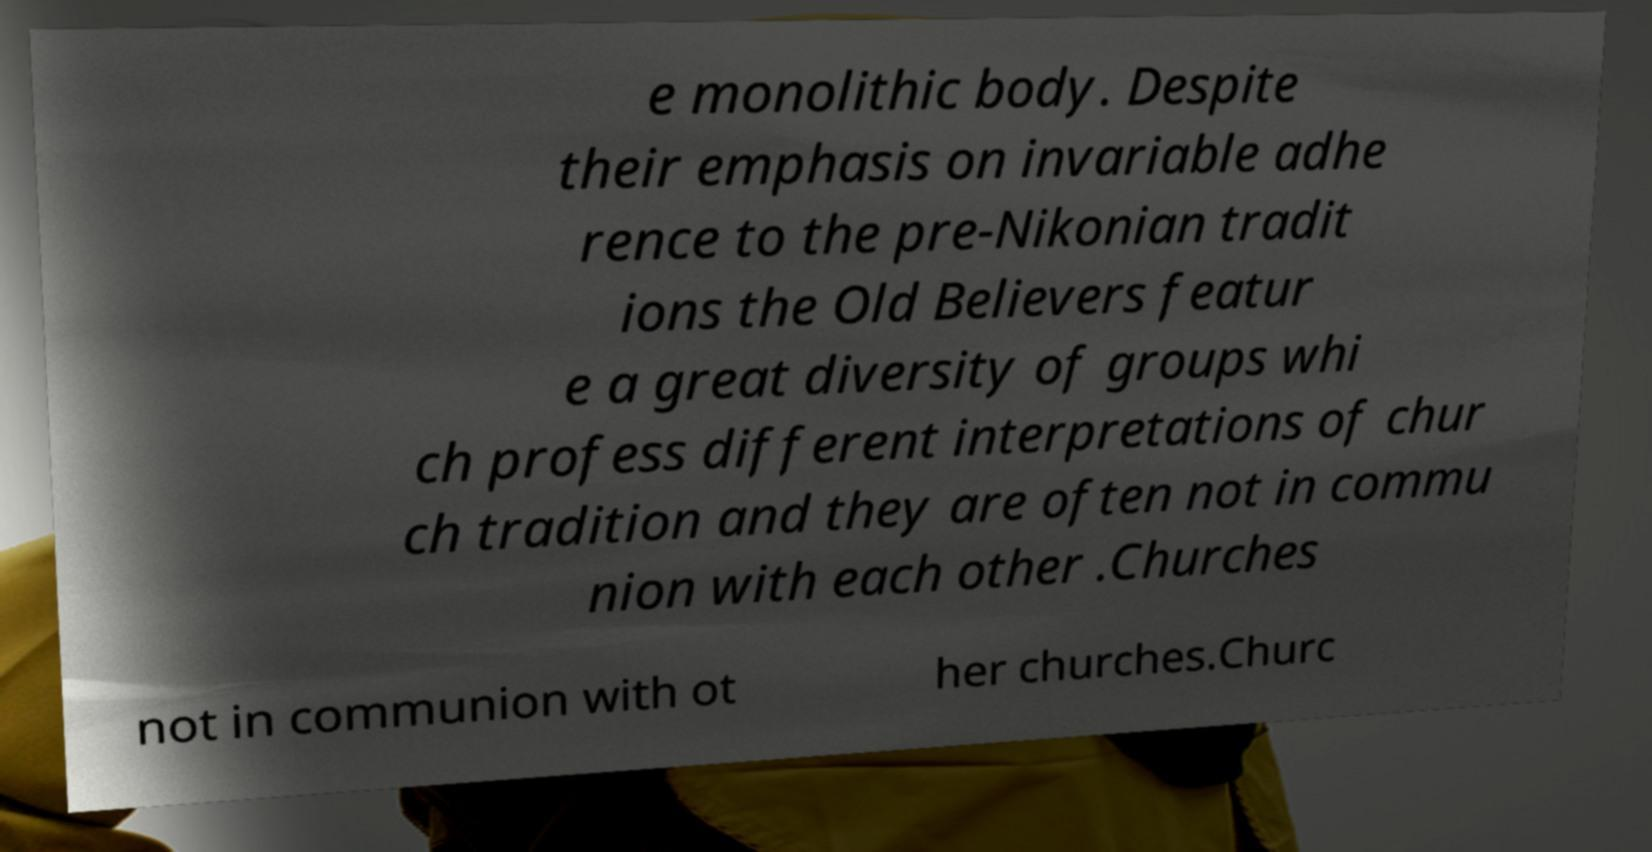Could you assist in decoding the text presented in this image and type it out clearly? e monolithic body. Despite their emphasis on invariable adhe rence to the pre-Nikonian tradit ions the Old Believers featur e a great diversity of groups whi ch profess different interpretations of chur ch tradition and they are often not in commu nion with each other .Churches not in communion with ot her churches.Churc 